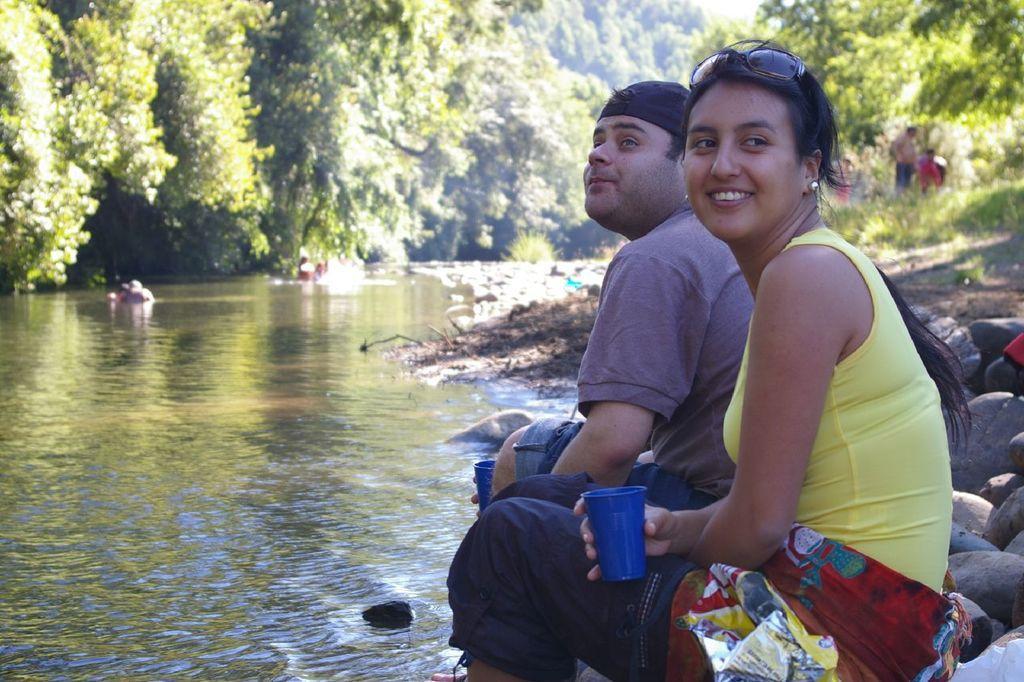Can you describe this image briefly? In this image, we can see a man and woman are sitting. Here a woman is holding a glass and smiling. On the right side, we can see stones, plants and few people. On the left side, we can see the water. Background there are so many trees and plants. Here we can see few people are in the water. 